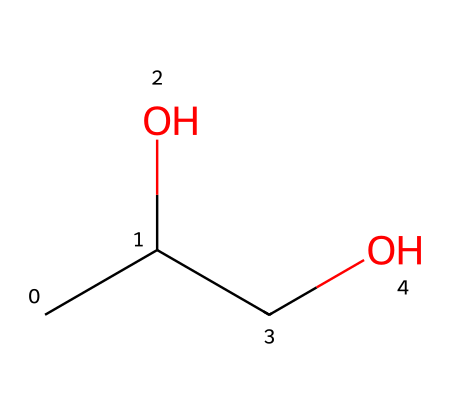How many carbon atoms are present in this molecule? To find the number of carbon atoms, we analyze the SMILES representation "CC(O)CO". The first "C" represents one carbon, the second "C" represents another carbon, and there is an additional "C" before the "O". Therefore, there are 3 carbon atoms in total.
Answer: 3 What is the molecular formula of propylene glycol? The SMILES representation indicates three carbon atoms (C), eight hydrogen atoms (H), and two oxygen atoms (O). Combining these gives us the molecular formula C3H8O2, which is the standard formula for propylene glycol.
Answer: C3H8O2 How many hydroxyl groups are in propylene glycol? In the SMILES "CC(O)CO", the "(O)" indicates that there is a hydroxyl group (-OH) attached to one of the carbon atoms. Since there are two positions on the carbon chain that connect to oxygen, we can count two hydroxyl groups.
Answer: 2 What functional group is present in this molecule? In the chemical structure represented by the SMILES "CC(O)CO", the hydroxyl groups indicated by "O" show that the molecule has alcohol functional groups. Alcohols contain one or more hydroxyl (-OH) groups, so this compound can be classified as an alcohol.
Answer: alcohol Is propylene glycol a polar solvent? Polar solvents are usually characterized by the presence of hydroxyl groups and uneven distribution of charge. The presence of two hydroxyl groups in the structure "CC(O)CO" indicates that the molecule can interact with water through hydrogen bonding, confirming it as a polar solvent.
Answer: yes 